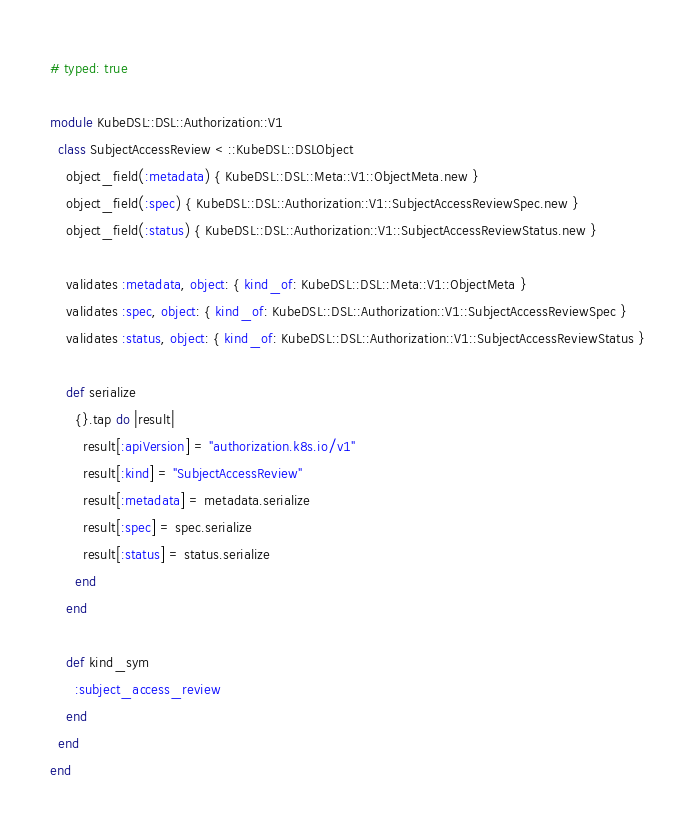<code> <loc_0><loc_0><loc_500><loc_500><_Ruby_># typed: true

module KubeDSL::DSL::Authorization::V1
  class SubjectAccessReview < ::KubeDSL::DSLObject
    object_field(:metadata) { KubeDSL::DSL::Meta::V1::ObjectMeta.new }
    object_field(:spec) { KubeDSL::DSL::Authorization::V1::SubjectAccessReviewSpec.new }
    object_field(:status) { KubeDSL::DSL::Authorization::V1::SubjectAccessReviewStatus.new }

    validates :metadata, object: { kind_of: KubeDSL::DSL::Meta::V1::ObjectMeta }
    validates :spec, object: { kind_of: KubeDSL::DSL::Authorization::V1::SubjectAccessReviewSpec }
    validates :status, object: { kind_of: KubeDSL::DSL::Authorization::V1::SubjectAccessReviewStatus }

    def serialize
      {}.tap do |result|
        result[:apiVersion] = "authorization.k8s.io/v1"
        result[:kind] = "SubjectAccessReview"
        result[:metadata] = metadata.serialize
        result[:spec] = spec.serialize
        result[:status] = status.serialize
      end
    end

    def kind_sym
      :subject_access_review
    end
  end
end
</code> 